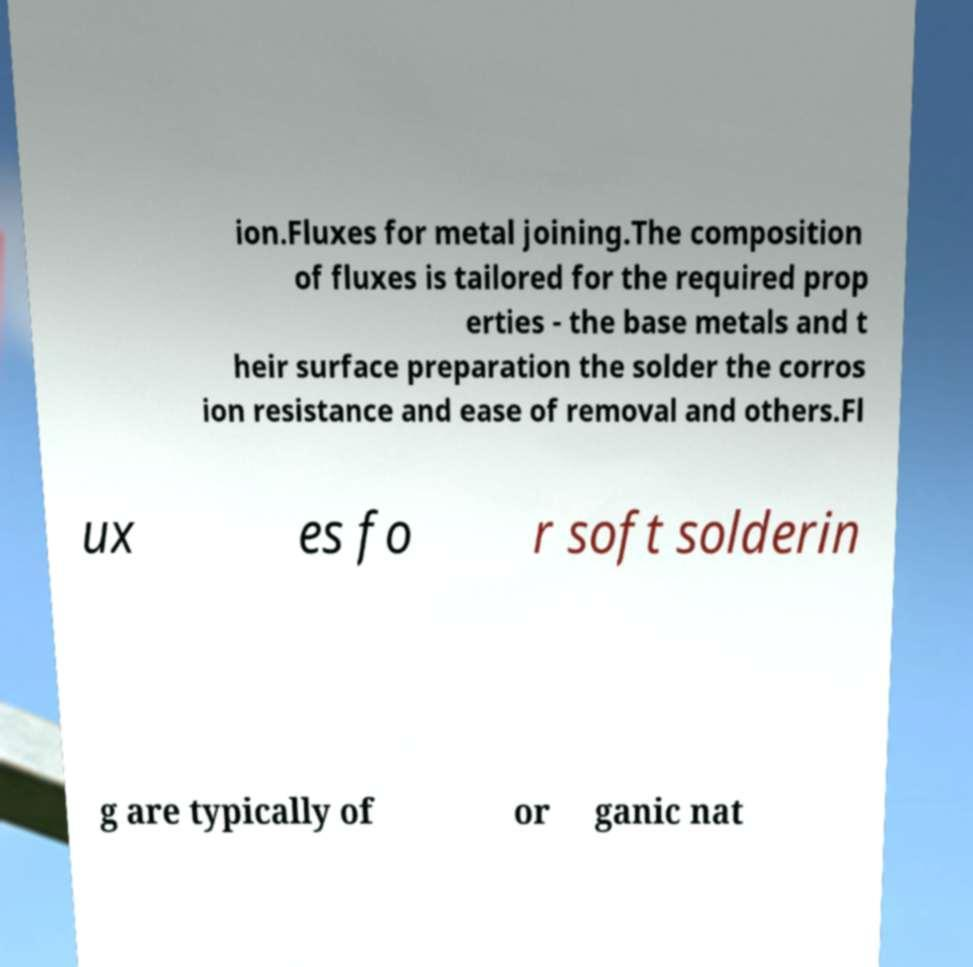Please identify and transcribe the text found in this image. ion.Fluxes for metal joining.The composition of fluxes is tailored for the required prop erties - the base metals and t heir surface preparation the solder the corros ion resistance and ease of removal and others.Fl ux es fo r soft solderin g are typically of or ganic nat 